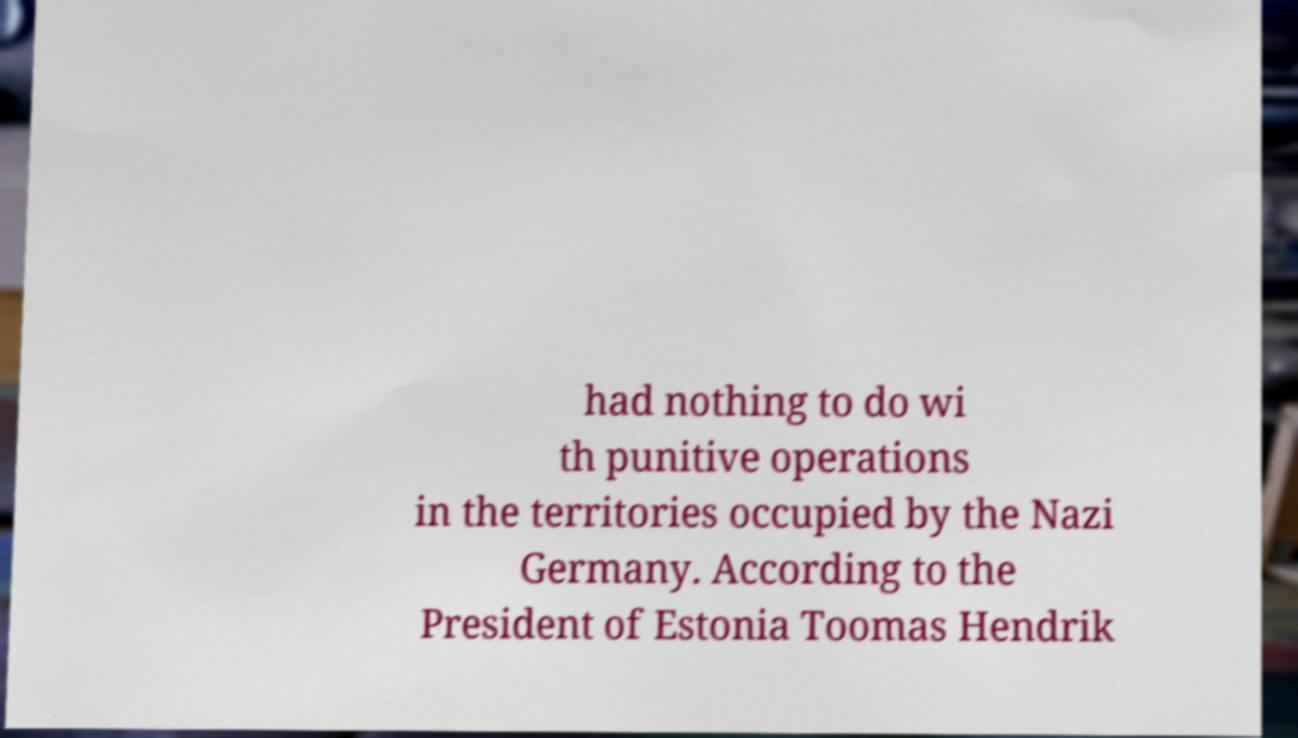Could you assist in decoding the text presented in this image and type it out clearly? had nothing to do wi th punitive operations in the territories occupied by the Nazi Germany. According to the President of Estonia Toomas Hendrik 